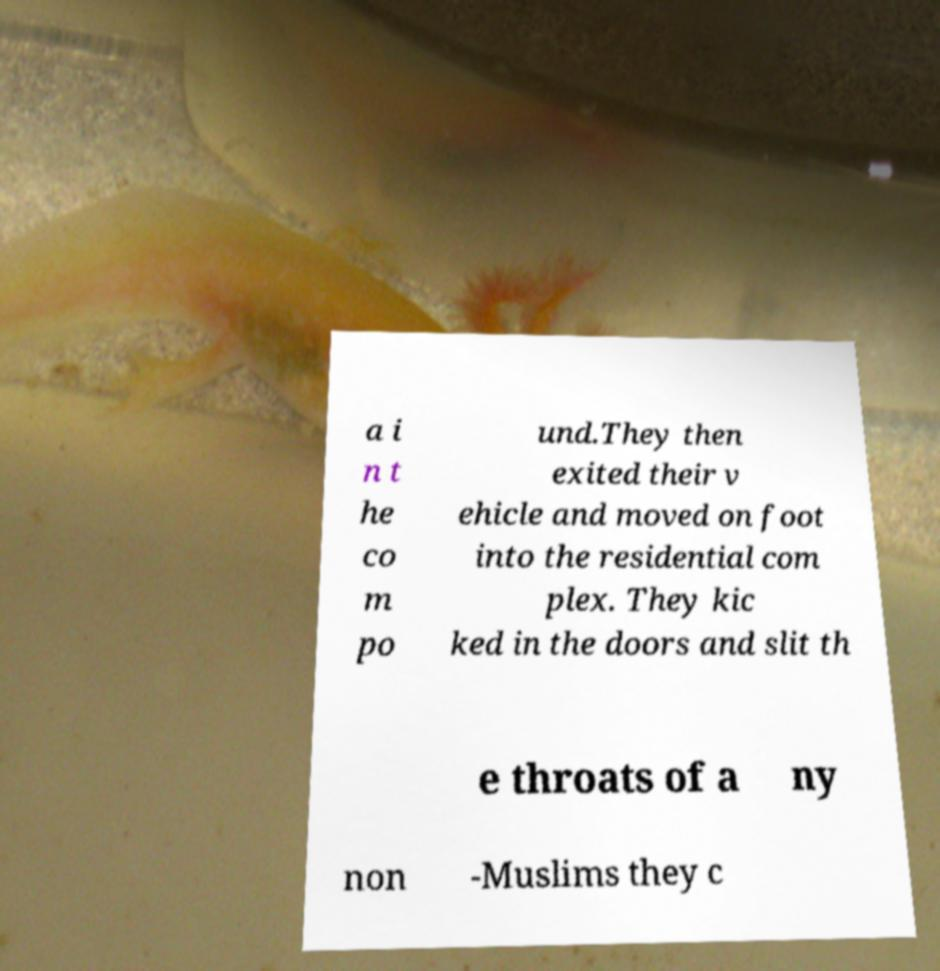For documentation purposes, I need the text within this image transcribed. Could you provide that? a i n t he co m po und.They then exited their v ehicle and moved on foot into the residential com plex. They kic ked in the doors and slit th e throats of a ny non -Muslims they c 